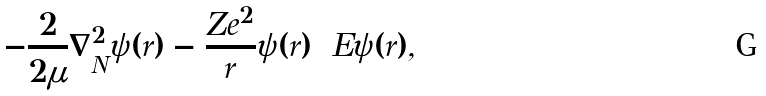Convert formula to latex. <formula><loc_0><loc_0><loc_500><loc_500>- \frac { 2 } { 2 \mu } \nabla _ { N } ^ { 2 } \psi ( r ) - \frac { Z e ^ { 2 } } { r } \psi ( r ) = E \psi ( r ) ,</formula> 